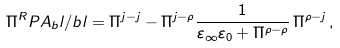Convert formula to latex. <formula><loc_0><loc_0><loc_500><loc_500>\Pi ^ { R } P A _ { b } l / b l = \Pi ^ { j - j } - \Pi ^ { j - \rho } \frac { 1 } { \varepsilon _ { \infty } \varepsilon _ { 0 } + \Pi ^ { \rho - \rho } } \, \Pi ^ { \rho - j } \, ,</formula> 